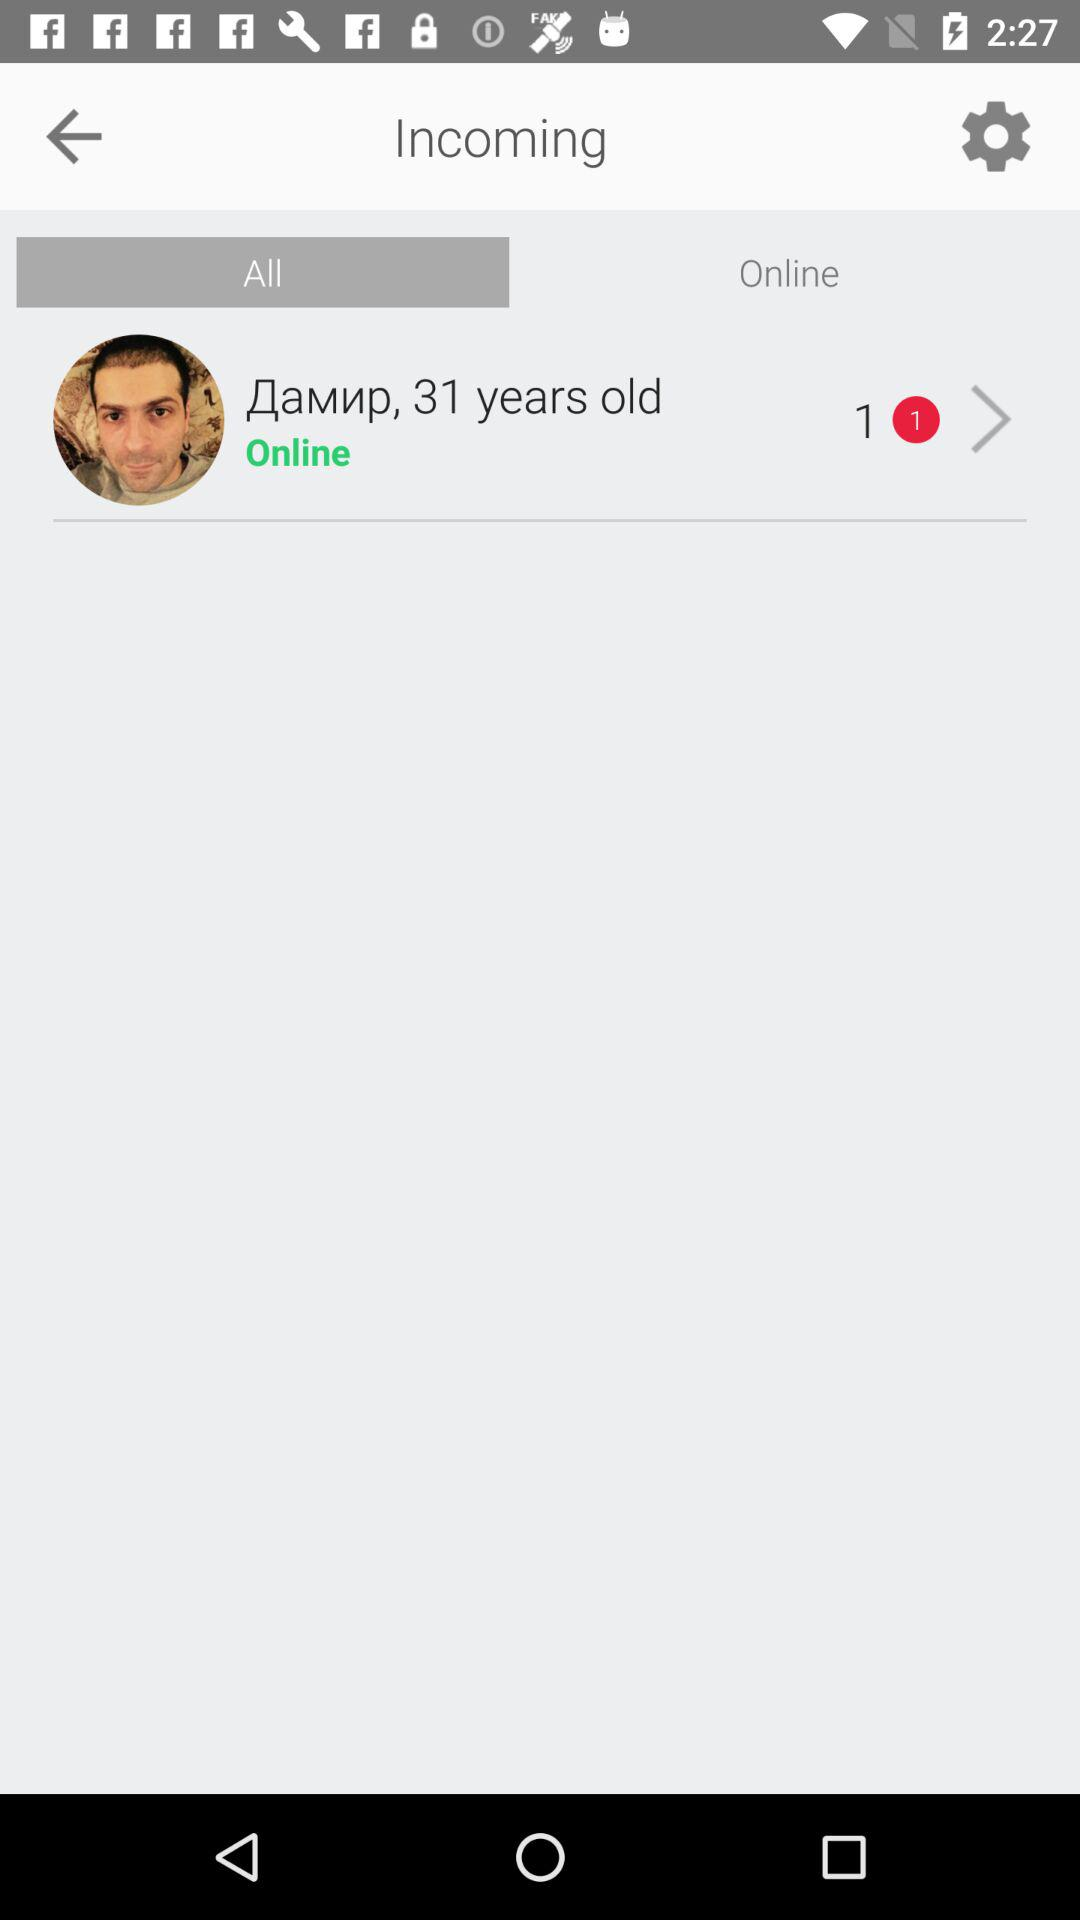How many unread messages does the user have?
Answer the question using a single word or phrase. 1 